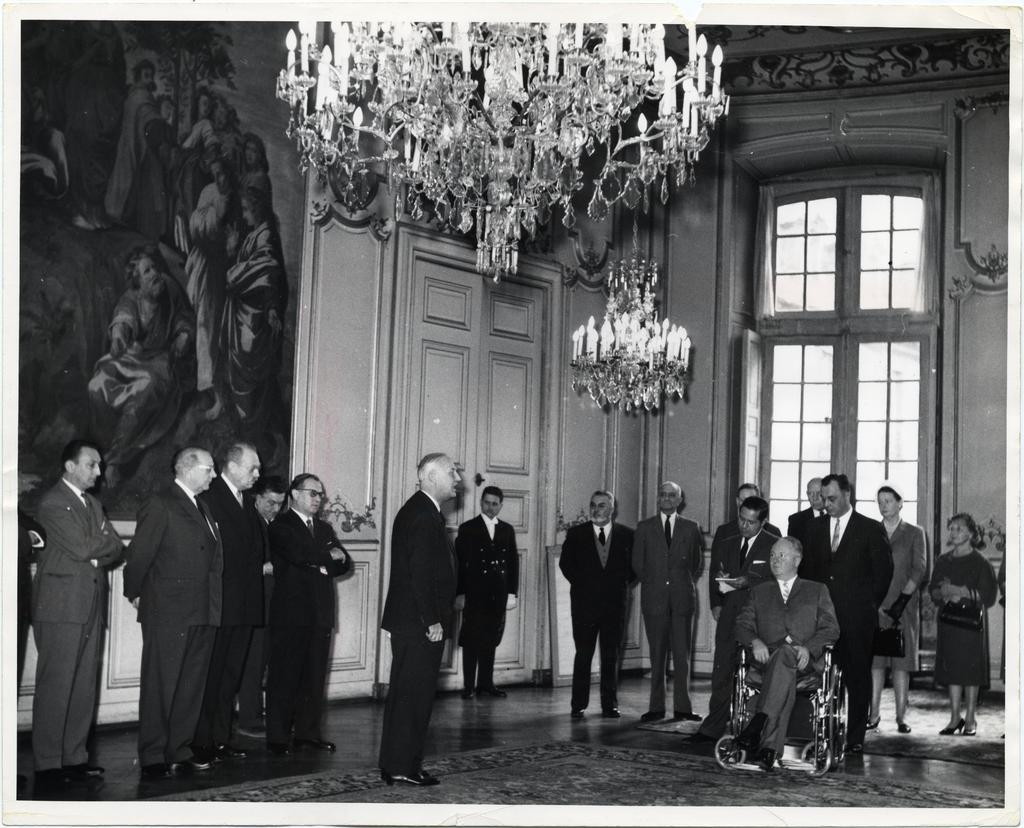What type of structure can be seen in the image? There is a wall in the image, which suggests a building or house. Are there any openings in the wall? Yes, there is a door and a window in the image. What type of lighting fixture is present in the image? There is a chandelier in the image. Are there any decorative items on display? Yes, there are photo frames in the image. Are there any people present in the image? Yes, there are people in the image, including a person sitting in a wheelchair. How many hands can be seen holding the girl in the image? There is no girl present in the image, and therefore no hands holding her. 